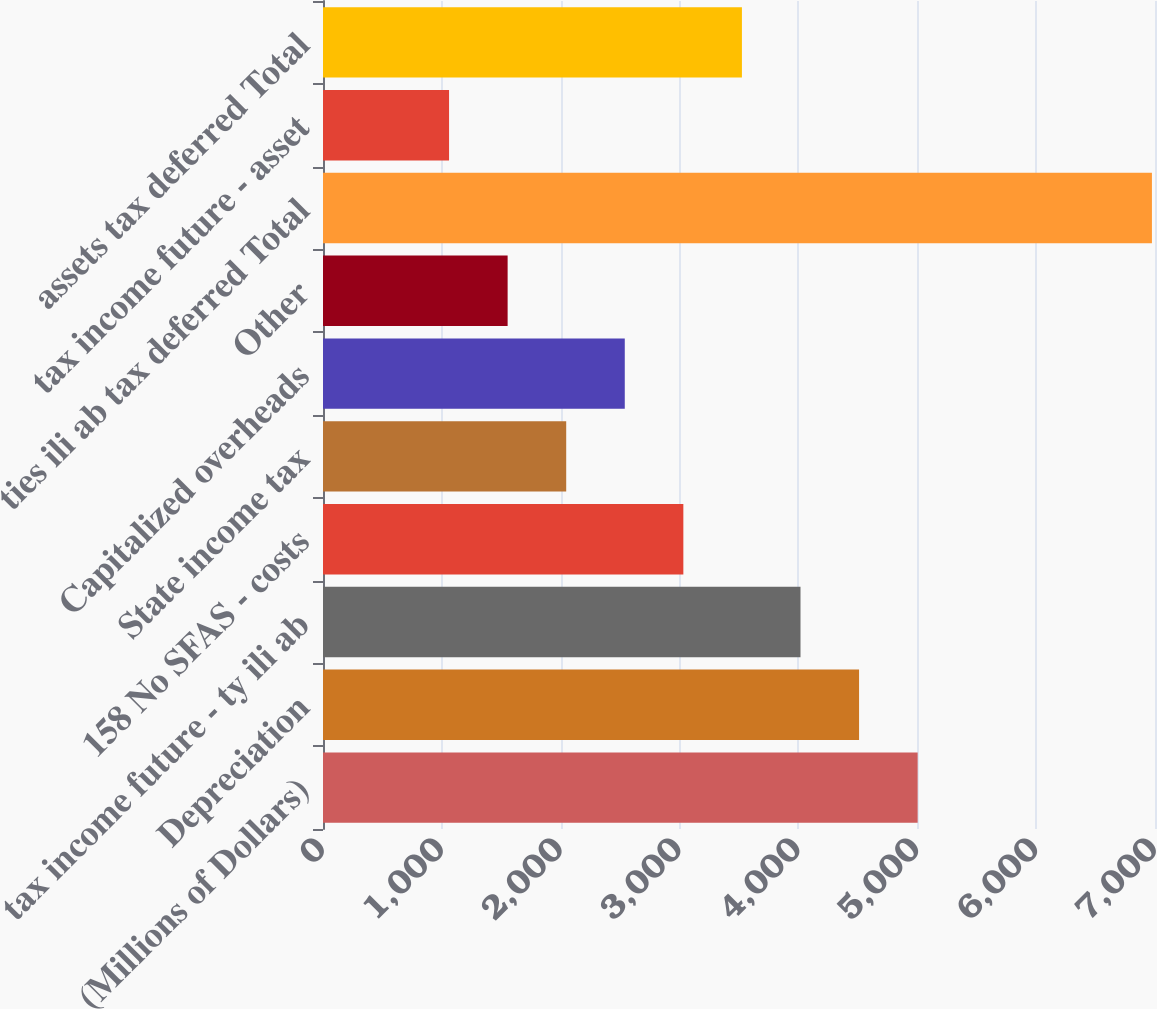Convert chart to OTSL. <chart><loc_0><loc_0><loc_500><loc_500><bar_chart><fcel>(Millions of Dollars)<fcel>Depreciation<fcel>tax income future - ty ili ab<fcel>158 No SFAS - costs<fcel>State income tax<fcel>Capitalized overheads<fcel>Other<fcel>ties ili ab tax deferred Total<fcel>tax income future - asset<fcel>assets tax deferred Total<nl><fcel>5003<fcel>4510.2<fcel>4017.4<fcel>3031.8<fcel>2046.2<fcel>2539<fcel>1553.4<fcel>6974.2<fcel>1060.6<fcel>3524.6<nl></chart> 